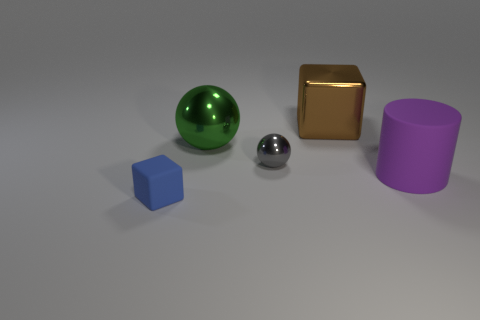Add 1 green things. How many objects exist? 6 Subtract 0 cyan blocks. How many objects are left? 5 Subtract all cubes. How many objects are left? 3 Subtract all cyan cylinders. Subtract all big cubes. How many objects are left? 4 Add 3 large matte objects. How many large matte objects are left? 4 Add 2 large green shiny balls. How many large green shiny balls exist? 3 